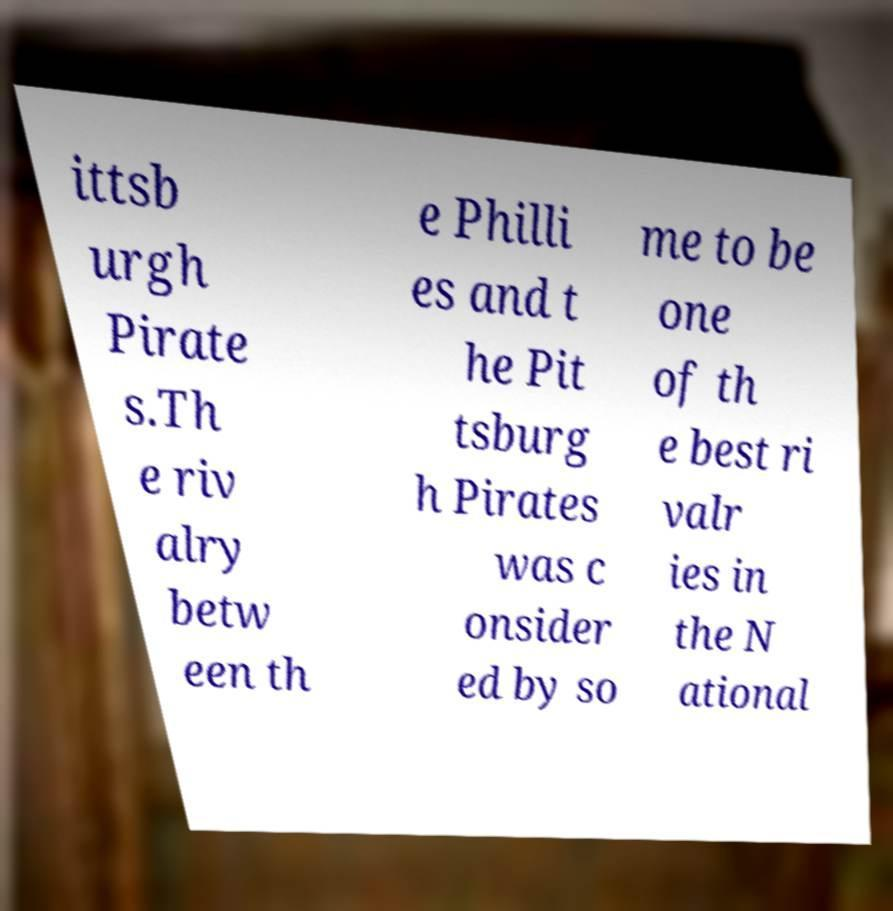There's text embedded in this image that I need extracted. Can you transcribe it verbatim? ittsb urgh Pirate s.Th e riv alry betw een th e Philli es and t he Pit tsburg h Pirates was c onsider ed by so me to be one of th e best ri valr ies in the N ational 